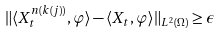Convert formula to latex. <formula><loc_0><loc_0><loc_500><loc_500>\| \langle X _ { t } ^ { n ( k ( j ) ) } , \varphi \rangle - \langle X _ { t } , \varphi \rangle \| _ { L ^ { 2 } ( \Omega ) } \geq \epsilon</formula> 